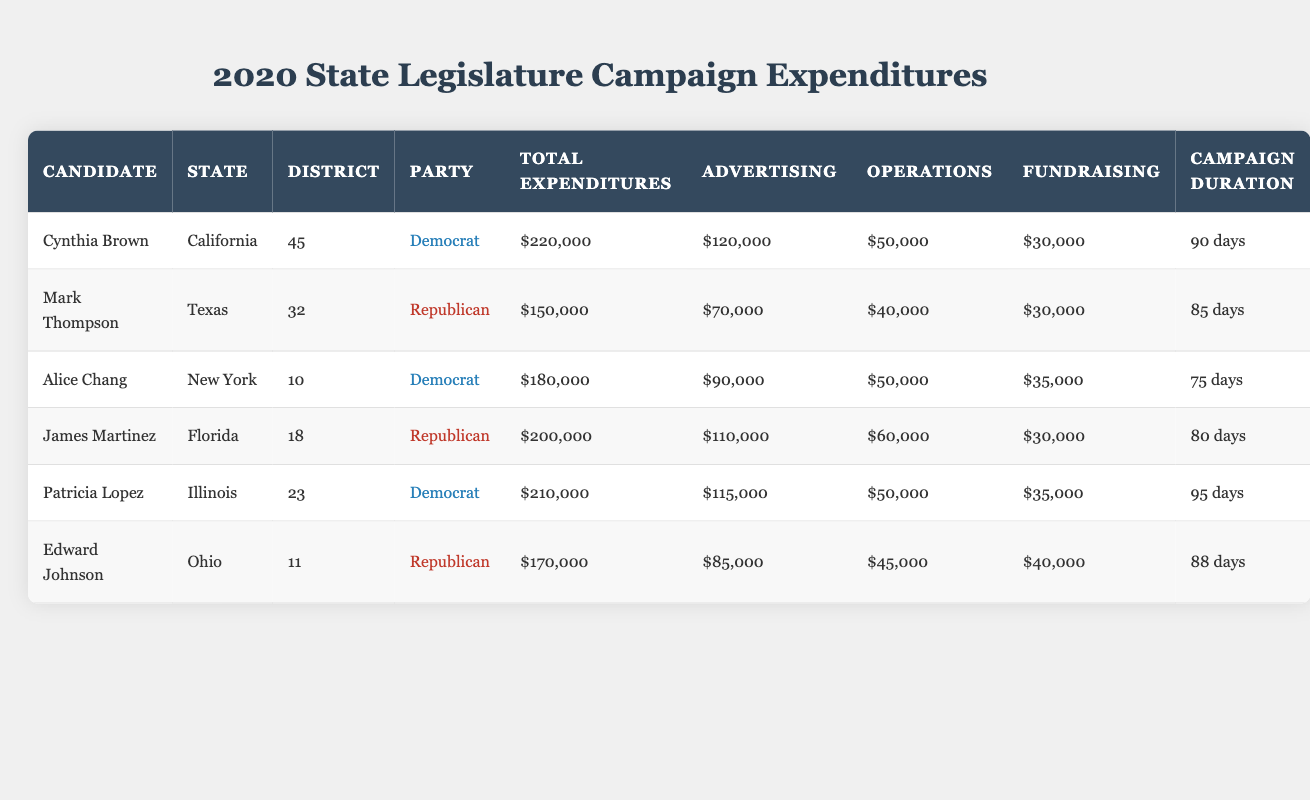What was the total expenditure of Cynthia Brown? To find the total expenditure of Cynthia Brown, look at her row in the table where her data is presented. The "Total Expenditures" column shows the value as 220,000.
Answer: 220,000 How many days did Patricia Lopez campaign for? By inspecting Patricia Lopez’s row in the table and looking under the "Campaign Duration" column, we find that the value is 95 days.
Answer: 95 days Which candidate had the highest total expenditures? We need to compare the "Total Expenditures" of all candidates listed. Checking the values, Cynthia Brown has 220,000, which is the highest among all candidates.
Answer: Cynthia Brown What are the total expenditures for candidates from the Republican Party? To calculate this, we should sum the total expenditures for all Republican candidates: Mark Thompson (150,000) + James Martinez (200,000) + Edward Johnson (170,000) = 520,000.
Answer: 520,000 Did Alice Chang have more expenditures than Mark Thompson? We compare Alice Chang's total expenditures of 180,000 with Mark Thompson's total of 150,000. Since 180,000 is greater than 150,000, the statement is true.
Answer: Yes Which state had the candidate with the second-highest advertising expenditure? First, look at the "Advertising" expenditures from the table. Cynthia Brown leads with 120,000, followed by James Martinez with 110,000. Hence, James Martinez representing Florida has the second-highest advertising expenditure.
Answer: Florida What is the average campaign duration for all candidates? To find the average campaign duration, sum up all the individual campaign durations: 90 + 85 + 75 + 80 + 95 + 88 = 513. Then, divide by the number of candidates, which is 6: 513 / 6 = 85.5.
Answer: 85.5 days Is it true that all candidates had more than $50,000 in advertising expenditure? We can check the advertising expenditures: Cynthia Brown (120,000), Mark Thompson (70,000), Alice Chang (90,000), James Martinez (110,000), Patricia Lopez (115,000), and Edward Johnson (85,000). All values are above 50,000, making this statement true.
Answer: Yes Which party had a candidate with the least amount spent on operations? Looking at the "Operations" column, the candidates' expenditures are: Cynthia Brown (50,000), Mark Thompson (40,000), Alice Chang (50,000), James Martinez (60,000), Patricia Lopez (50,000), and Edward Johnson (45,000). The least is from Mark Thompson with 40,000. Therefore, the Republican Party had the candidate with the least spending on operations.
Answer: Republican Party 